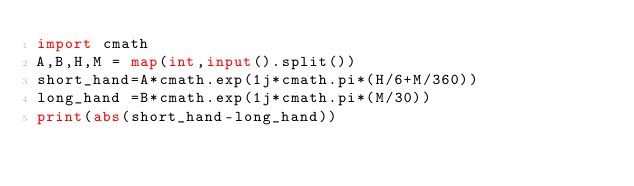<code> <loc_0><loc_0><loc_500><loc_500><_Python_>import cmath
A,B,H,M = map(int,input().split())
short_hand=A*cmath.exp(1j*cmath.pi*(H/6+M/360))
long_hand =B*cmath.exp(1j*cmath.pi*(M/30))
print(abs(short_hand-long_hand))</code> 